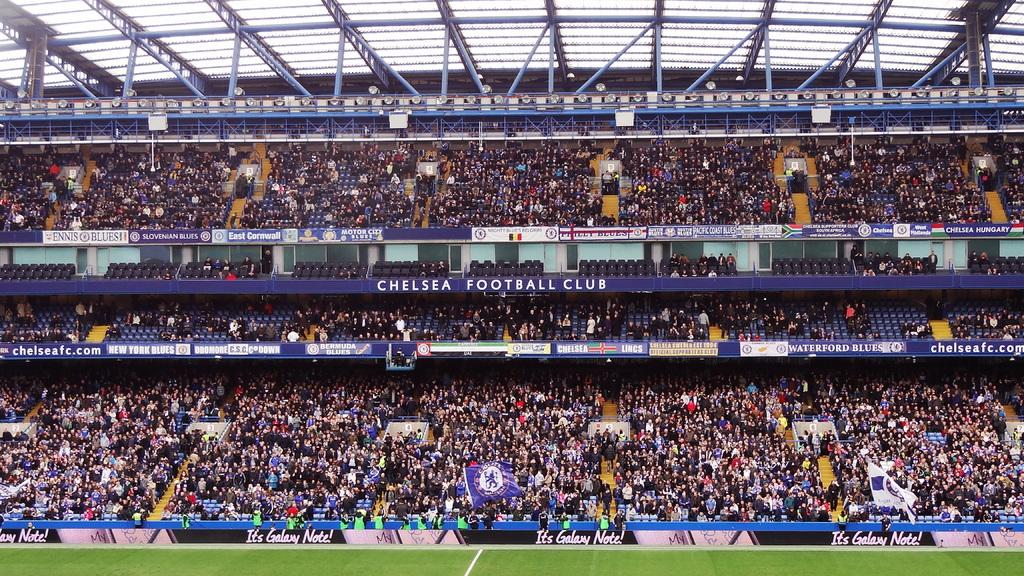Provide a one-sentence caption for the provided image. Many people are in the stands at the Chelsea Football Club stadium. 